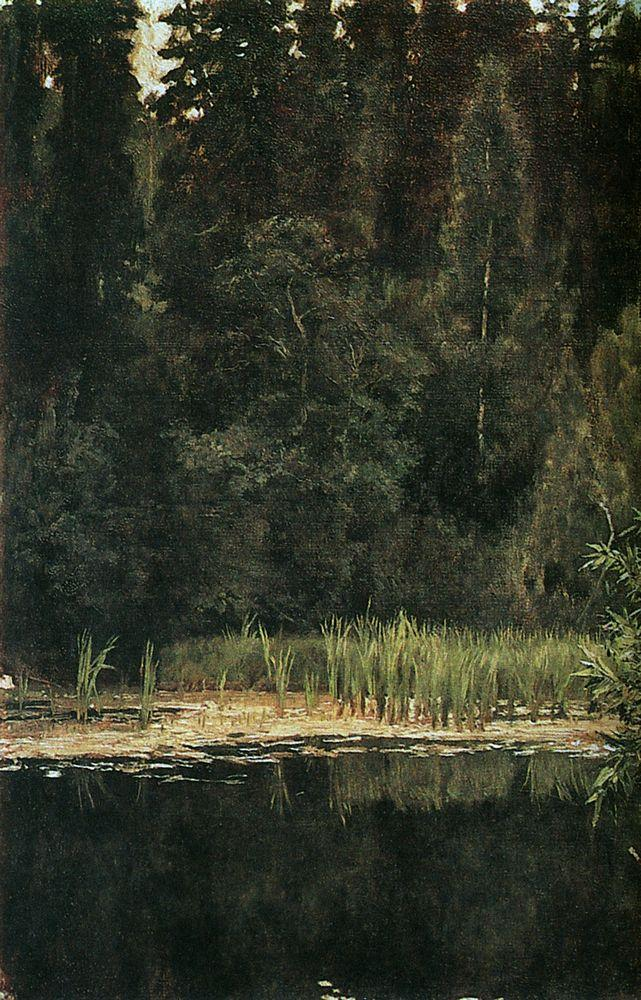What time of day does this painting represent and why? The dim lighting and the muted palette with dark greens and browns suggest that this scene is set during twilight, perhaps just before sunset. The shadows cast by the trees are long and diffuse, indicating the sun is low on the horizon. The absence of strong light reflections in the water strengthens the likelihood of evening. One can sense a calmness associated with the end of the day, where the forest starts to settle for the night. 